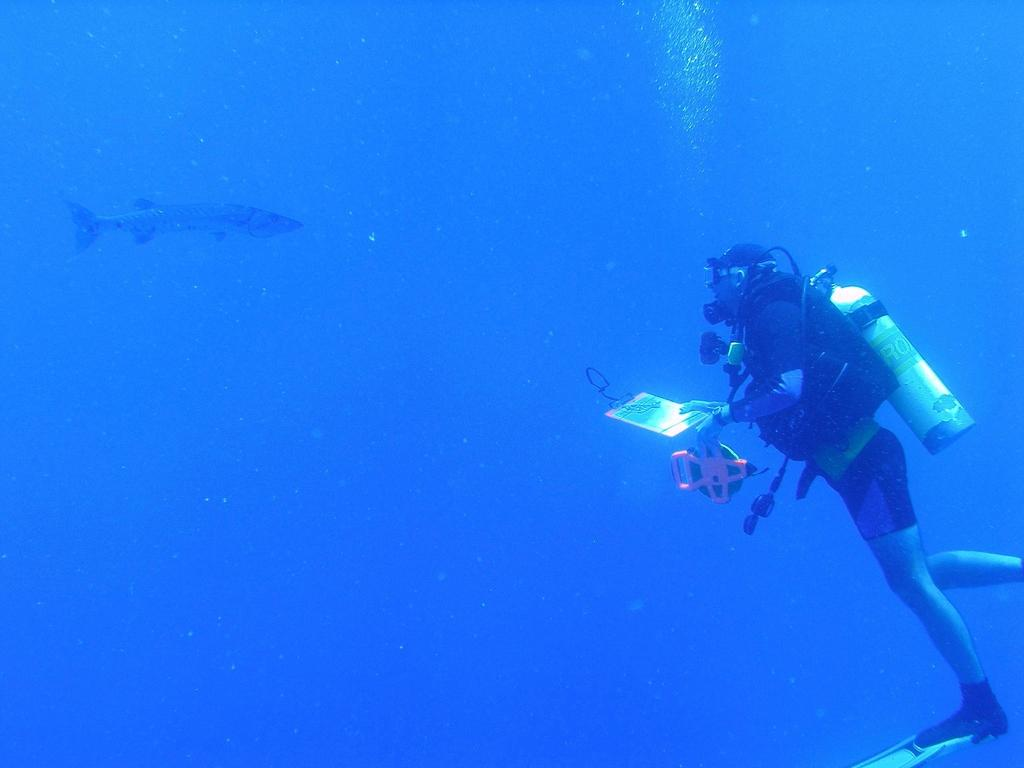What is the primary element in the image? There is water in the image. What can be seen in the water? Fish are visible in the water. What else is present in the image besides the water and fish? There is a boat and a person in the image. What is the person holding? The person is holding an object. What is the person wearing on their face? The person is wearing a mask. What is the person carrying? The person is carrying a cylinder. What type of roof can be seen in the image? There is no roof present in the image. How does the person look at the fish in the image? The image does not show the person looking at the fish, so it cannot be determined from the image. 